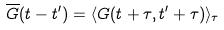Convert formula to latex. <formula><loc_0><loc_0><loc_500><loc_500>\overline { G } ( t - t ^ { \prime } ) = \langle G ( t + \tau , t ^ { \prime } + \tau ) \rangle _ { \tau }</formula> 